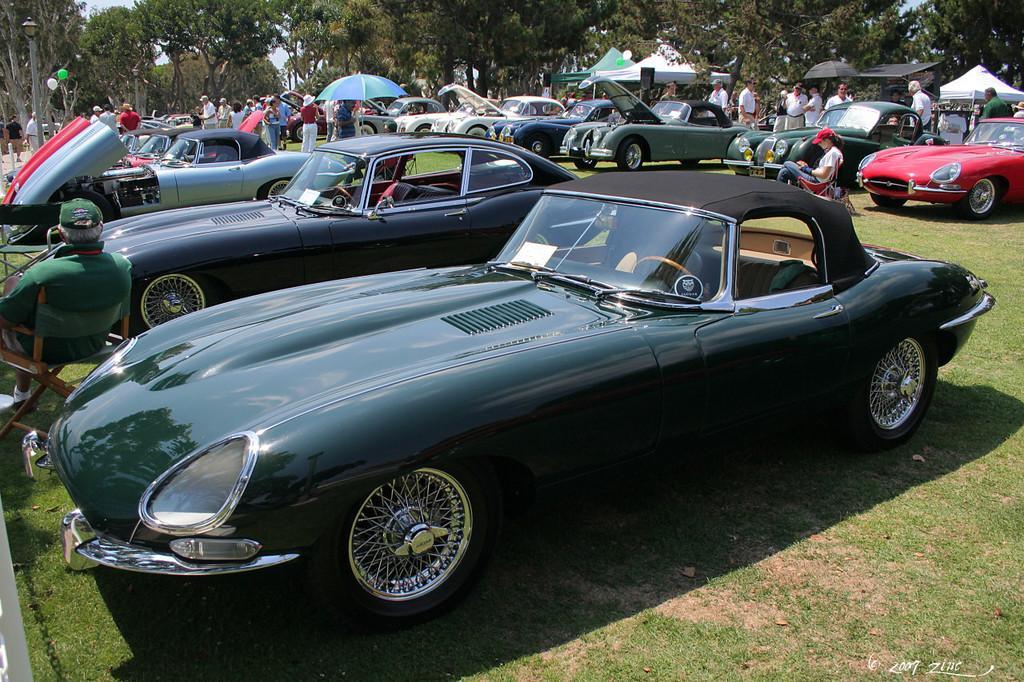Describe this image in one or two sentences. In this image we can see group of vehicles parked on the ground, some persons are sitting on chairs placed on the ground. In the center of the image we can see group of persons standing on the ground, some tents and umbrellas. In the background, we can see a group of trees, light poles and the sky. 